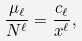<formula> <loc_0><loc_0><loc_500><loc_500>\frac { \mu _ { \ell } } { N ^ { \ell } } = \frac { c _ { \ell } } { x ^ { \ell } } ,</formula> 